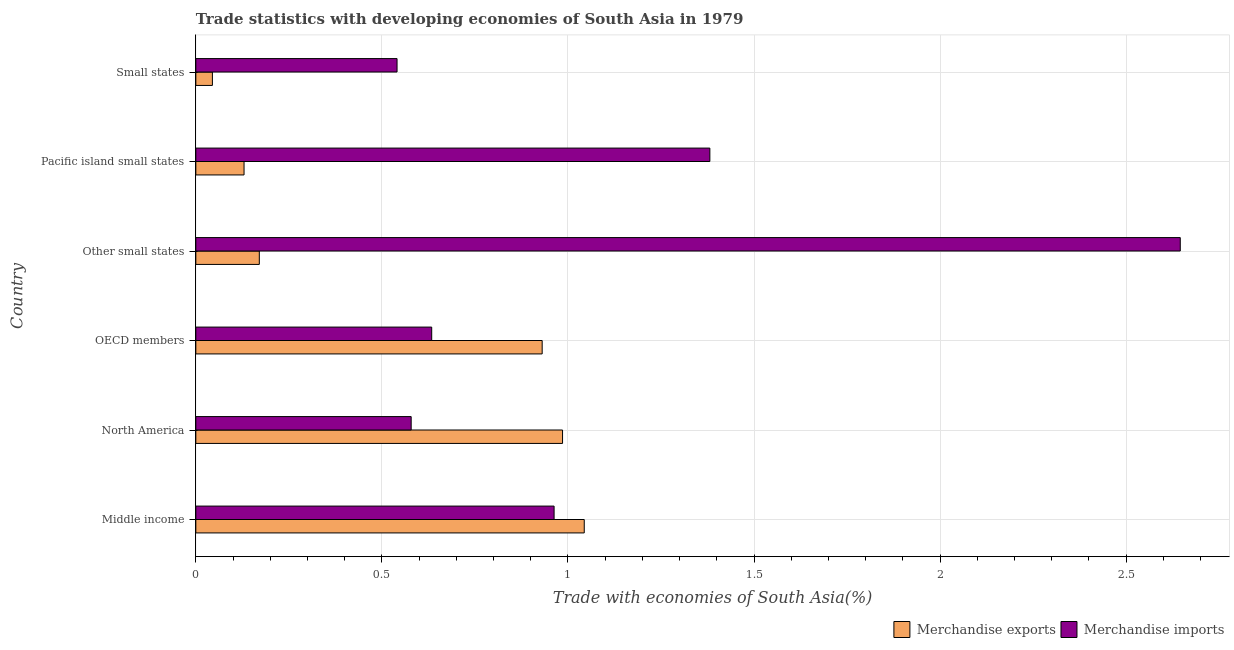How many different coloured bars are there?
Offer a terse response. 2. Are the number of bars on each tick of the Y-axis equal?
Offer a very short reply. Yes. How many bars are there on the 1st tick from the top?
Your answer should be compact. 2. How many bars are there on the 6th tick from the bottom?
Offer a terse response. 2. What is the merchandise exports in Small states?
Make the answer very short. 0.04. Across all countries, what is the maximum merchandise exports?
Your answer should be compact. 1.04. Across all countries, what is the minimum merchandise exports?
Your answer should be very brief. 0.04. In which country was the merchandise imports minimum?
Your answer should be compact. Small states. What is the total merchandise exports in the graph?
Offer a terse response. 3.3. What is the difference between the merchandise exports in OECD members and that in Small states?
Your response must be concise. 0.89. What is the difference between the merchandise exports in Middle income and the merchandise imports in Small states?
Keep it short and to the point. 0.5. What is the average merchandise exports per country?
Offer a very short reply. 0.55. What is the difference between the merchandise imports and merchandise exports in OECD members?
Ensure brevity in your answer.  -0.3. In how many countries, is the merchandise exports greater than 1.2 %?
Provide a short and direct response. 0. What is the ratio of the merchandise imports in Middle income to that in North America?
Make the answer very short. 1.66. Is the merchandise imports in Middle income less than that in Pacific island small states?
Keep it short and to the point. Yes. What is the difference between the highest and the second highest merchandise exports?
Your answer should be very brief. 0.06. What does the 1st bar from the top in Small states represents?
Your answer should be very brief. Merchandise imports. Are all the bars in the graph horizontal?
Keep it short and to the point. Yes. How many countries are there in the graph?
Your answer should be very brief. 6. What is the difference between two consecutive major ticks on the X-axis?
Give a very brief answer. 0.5. Does the graph contain grids?
Your answer should be compact. Yes. What is the title of the graph?
Provide a short and direct response. Trade statistics with developing economies of South Asia in 1979. What is the label or title of the X-axis?
Your answer should be compact. Trade with economies of South Asia(%). What is the label or title of the Y-axis?
Offer a terse response. Country. What is the Trade with economies of South Asia(%) in Merchandise exports in Middle income?
Offer a terse response. 1.04. What is the Trade with economies of South Asia(%) of Merchandise imports in Middle income?
Keep it short and to the point. 0.96. What is the Trade with economies of South Asia(%) in Merchandise exports in North America?
Provide a succinct answer. 0.99. What is the Trade with economies of South Asia(%) of Merchandise imports in North America?
Your response must be concise. 0.58. What is the Trade with economies of South Asia(%) in Merchandise exports in OECD members?
Make the answer very short. 0.93. What is the Trade with economies of South Asia(%) of Merchandise imports in OECD members?
Offer a terse response. 0.63. What is the Trade with economies of South Asia(%) in Merchandise exports in Other small states?
Ensure brevity in your answer.  0.17. What is the Trade with economies of South Asia(%) of Merchandise imports in Other small states?
Your response must be concise. 2.65. What is the Trade with economies of South Asia(%) in Merchandise exports in Pacific island small states?
Offer a terse response. 0.13. What is the Trade with economies of South Asia(%) in Merchandise imports in Pacific island small states?
Keep it short and to the point. 1.38. What is the Trade with economies of South Asia(%) of Merchandise exports in Small states?
Keep it short and to the point. 0.04. What is the Trade with economies of South Asia(%) in Merchandise imports in Small states?
Offer a very short reply. 0.54. Across all countries, what is the maximum Trade with economies of South Asia(%) of Merchandise exports?
Your response must be concise. 1.04. Across all countries, what is the maximum Trade with economies of South Asia(%) in Merchandise imports?
Your response must be concise. 2.65. Across all countries, what is the minimum Trade with economies of South Asia(%) of Merchandise exports?
Offer a very short reply. 0.04. Across all countries, what is the minimum Trade with economies of South Asia(%) of Merchandise imports?
Give a very brief answer. 0.54. What is the total Trade with economies of South Asia(%) of Merchandise exports in the graph?
Provide a succinct answer. 3.3. What is the total Trade with economies of South Asia(%) in Merchandise imports in the graph?
Make the answer very short. 6.74. What is the difference between the Trade with economies of South Asia(%) in Merchandise exports in Middle income and that in North America?
Ensure brevity in your answer.  0.06. What is the difference between the Trade with economies of South Asia(%) of Merchandise imports in Middle income and that in North America?
Offer a very short reply. 0.38. What is the difference between the Trade with economies of South Asia(%) in Merchandise exports in Middle income and that in OECD members?
Provide a succinct answer. 0.11. What is the difference between the Trade with economies of South Asia(%) of Merchandise imports in Middle income and that in OECD members?
Your answer should be compact. 0.33. What is the difference between the Trade with economies of South Asia(%) of Merchandise exports in Middle income and that in Other small states?
Offer a terse response. 0.87. What is the difference between the Trade with economies of South Asia(%) of Merchandise imports in Middle income and that in Other small states?
Your answer should be compact. -1.68. What is the difference between the Trade with economies of South Asia(%) in Merchandise exports in Middle income and that in Pacific island small states?
Your answer should be very brief. 0.91. What is the difference between the Trade with economies of South Asia(%) of Merchandise imports in Middle income and that in Pacific island small states?
Provide a short and direct response. -0.42. What is the difference between the Trade with economies of South Asia(%) in Merchandise exports in Middle income and that in Small states?
Provide a short and direct response. 1. What is the difference between the Trade with economies of South Asia(%) in Merchandise imports in Middle income and that in Small states?
Your answer should be very brief. 0.42. What is the difference between the Trade with economies of South Asia(%) in Merchandise exports in North America and that in OECD members?
Provide a succinct answer. 0.05. What is the difference between the Trade with economies of South Asia(%) of Merchandise imports in North America and that in OECD members?
Offer a very short reply. -0.06. What is the difference between the Trade with economies of South Asia(%) of Merchandise exports in North America and that in Other small states?
Your answer should be compact. 0.81. What is the difference between the Trade with economies of South Asia(%) of Merchandise imports in North America and that in Other small states?
Offer a terse response. -2.07. What is the difference between the Trade with economies of South Asia(%) in Merchandise exports in North America and that in Pacific island small states?
Your answer should be very brief. 0.86. What is the difference between the Trade with economies of South Asia(%) in Merchandise imports in North America and that in Pacific island small states?
Offer a terse response. -0.8. What is the difference between the Trade with economies of South Asia(%) in Merchandise exports in North America and that in Small states?
Provide a short and direct response. 0.94. What is the difference between the Trade with economies of South Asia(%) of Merchandise imports in North America and that in Small states?
Provide a short and direct response. 0.04. What is the difference between the Trade with economies of South Asia(%) of Merchandise exports in OECD members and that in Other small states?
Offer a very short reply. 0.76. What is the difference between the Trade with economies of South Asia(%) in Merchandise imports in OECD members and that in Other small states?
Ensure brevity in your answer.  -2.01. What is the difference between the Trade with economies of South Asia(%) of Merchandise exports in OECD members and that in Pacific island small states?
Ensure brevity in your answer.  0.8. What is the difference between the Trade with economies of South Asia(%) in Merchandise imports in OECD members and that in Pacific island small states?
Keep it short and to the point. -0.75. What is the difference between the Trade with economies of South Asia(%) in Merchandise exports in OECD members and that in Small states?
Ensure brevity in your answer.  0.89. What is the difference between the Trade with economies of South Asia(%) in Merchandise imports in OECD members and that in Small states?
Keep it short and to the point. 0.09. What is the difference between the Trade with economies of South Asia(%) in Merchandise exports in Other small states and that in Pacific island small states?
Ensure brevity in your answer.  0.04. What is the difference between the Trade with economies of South Asia(%) in Merchandise imports in Other small states and that in Pacific island small states?
Give a very brief answer. 1.26. What is the difference between the Trade with economies of South Asia(%) in Merchandise exports in Other small states and that in Small states?
Offer a very short reply. 0.13. What is the difference between the Trade with economies of South Asia(%) in Merchandise imports in Other small states and that in Small states?
Offer a terse response. 2.1. What is the difference between the Trade with economies of South Asia(%) in Merchandise exports in Pacific island small states and that in Small states?
Offer a very short reply. 0.09. What is the difference between the Trade with economies of South Asia(%) of Merchandise imports in Pacific island small states and that in Small states?
Your answer should be very brief. 0.84. What is the difference between the Trade with economies of South Asia(%) of Merchandise exports in Middle income and the Trade with economies of South Asia(%) of Merchandise imports in North America?
Make the answer very short. 0.47. What is the difference between the Trade with economies of South Asia(%) in Merchandise exports in Middle income and the Trade with economies of South Asia(%) in Merchandise imports in OECD members?
Keep it short and to the point. 0.41. What is the difference between the Trade with economies of South Asia(%) of Merchandise exports in Middle income and the Trade with economies of South Asia(%) of Merchandise imports in Other small states?
Keep it short and to the point. -1.6. What is the difference between the Trade with economies of South Asia(%) in Merchandise exports in Middle income and the Trade with economies of South Asia(%) in Merchandise imports in Pacific island small states?
Keep it short and to the point. -0.34. What is the difference between the Trade with economies of South Asia(%) in Merchandise exports in Middle income and the Trade with economies of South Asia(%) in Merchandise imports in Small states?
Give a very brief answer. 0.5. What is the difference between the Trade with economies of South Asia(%) in Merchandise exports in North America and the Trade with economies of South Asia(%) in Merchandise imports in OECD members?
Offer a very short reply. 0.35. What is the difference between the Trade with economies of South Asia(%) of Merchandise exports in North America and the Trade with economies of South Asia(%) of Merchandise imports in Other small states?
Your answer should be compact. -1.66. What is the difference between the Trade with economies of South Asia(%) in Merchandise exports in North America and the Trade with economies of South Asia(%) in Merchandise imports in Pacific island small states?
Provide a short and direct response. -0.4. What is the difference between the Trade with economies of South Asia(%) of Merchandise exports in North America and the Trade with economies of South Asia(%) of Merchandise imports in Small states?
Offer a terse response. 0.44. What is the difference between the Trade with economies of South Asia(%) of Merchandise exports in OECD members and the Trade with economies of South Asia(%) of Merchandise imports in Other small states?
Your answer should be compact. -1.71. What is the difference between the Trade with economies of South Asia(%) in Merchandise exports in OECD members and the Trade with economies of South Asia(%) in Merchandise imports in Pacific island small states?
Keep it short and to the point. -0.45. What is the difference between the Trade with economies of South Asia(%) of Merchandise exports in OECD members and the Trade with economies of South Asia(%) of Merchandise imports in Small states?
Your answer should be very brief. 0.39. What is the difference between the Trade with economies of South Asia(%) of Merchandise exports in Other small states and the Trade with economies of South Asia(%) of Merchandise imports in Pacific island small states?
Provide a short and direct response. -1.21. What is the difference between the Trade with economies of South Asia(%) of Merchandise exports in Other small states and the Trade with economies of South Asia(%) of Merchandise imports in Small states?
Offer a very short reply. -0.37. What is the difference between the Trade with economies of South Asia(%) in Merchandise exports in Pacific island small states and the Trade with economies of South Asia(%) in Merchandise imports in Small states?
Offer a terse response. -0.41. What is the average Trade with economies of South Asia(%) of Merchandise exports per country?
Ensure brevity in your answer.  0.55. What is the average Trade with economies of South Asia(%) in Merchandise imports per country?
Provide a succinct answer. 1.12. What is the difference between the Trade with economies of South Asia(%) of Merchandise exports and Trade with economies of South Asia(%) of Merchandise imports in Middle income?
Your answer should be very brief. 0.08. What is the difference between the Trade with economies of South Asia(%) in Merchandise exports and Trade with economies of South Asia(%) in Merchandise imports in North America?
Offer a terse response. 0.41. What is the difference between the Trade with economies of South Asia(%) in Merchandise exports and Trade with economies of South Asia(%) in Merchandise imports in OECD members?
Offer a very short reply. 0.3. What is the difference between the Trade with economies of South Asia(%) in Merchandise exports and Trade with economies of South Asia(%) in Merchandise imports in Other small states?
Offer a terse response. -2.47. What is the difference between the Trade with economies of South Asia(%) in Merchandise exports and Trade with economies of South Asia(%) in Merchandise imports in Pacific island small states?
Give a very brief answer. -1.25. What is the difference between the Trade with economies of South Asia(%) in Merchandise exports and Trade with economies of South Asia(%) in Merchandise imports in Small states?
Your answer should be compact. -0.5. What is the ratio of the Trade with economies of South Asia(%) of Merchandise exports in Middle income to that in North America?
Your answer should be compact. 1.06. What is the ratio of the Trade with economies of South Asia(%) of Merchandise imports in Middle income to that in North America?
Make the answer very short. 1.66. What is the ratio of the Trade with economies of South Asia(%) of Merchandise exports in Middle income to that in OECD members?
Offer a terse response. 1.12. What is the ratio of the Trade with economies of South Asia(%) of Merchandise imports in Middle income to that in OECD members?
Your response must be concise. 1.52. What is the ratio of the Trade with economies of South Asia(%) of Merchandise exports in Middle income to that in Other small states?
Offer a terse response. 6.12. What is the ratio of the Trade with economies of South Asia(%) of Merchandise imports in Middle income to that in Other small states?
Offer a very short reply. 0.36. What is the ratio of the Trade with economies of South Asia(%) of Merchandise exports in Middle income to that in Pacific island small states?
Your answer should be very brief. 8.05. What is the ratio of the Trade with economies of South Asia(%) in Merchandise imports in Middle income to that in Pacific island small states?
Give a very brief answer. 0.7. What is the ratio of the Trade with economies of South Asia(%) of Merchandise exports in Middle income to that in Small states?
Your answer should be compact. 23.44. What is the ratio of the Trade with economies of South Asia(%) of Merchandise imports in Middle income to that in Small states?
Give a very brief answer. 1.78. What is the ratio of the Trade with economies of South Asia(%) in Merchandise exports in North America to that in OECD members?
Provide a succinct answer. 1.06. What is the ratio of the Trade with economies of South Asia(%) of Merchandise exports in North America to that in Other small states?
Ensure brevity in your answer.  5.78. What is the ratio of the Trade with economies of South Asia(%) in Merchandise imports in North America to that in Other small states?
Your answer should be compact. 0.22. What is the ratio of the Trade with economies of South Asia(%) of Merchandise exports in North America to that in Pacific island small states?
Make the answer very short. 7.6. What is the ratio of the Trade with economies of South Asia(%) of Merchandise imports in North America to that in Pacific island small states?
Offer a very short reply. 0.42. What is the ratio of the Trade with economies of South Asia(%) of Merchandise exports in North America to that in Small states?
Make the answer very short. 22.13. What is the ratio of the Trade with economies of South Asia(%) of Merchandise imports in North America to that in Small states?
Offer a very short reply. 1.07. What is the ratio of the Trade with economies of South Asia(%) in Merchandise exports in OECD members to that in Other small states?
Give a very brief answer. 5.46. What is the ratio of the Trade with economies of South Asia(%) in Merchandise imports in OECD members to that in Other small states?
Your response must be concise. 0.24. What is the ratio of the Trade with economies of South Asia(%) in Merchandise exports in OECD members to that in Pacific island small states?
Ensure brevity in your answer.  7.18. What is the ratio of the Trade with economies of South Asia(%) of Merchandise imports in OECD members to that in Pacific island small states?
Keep it short and to the point. 0.46. What is the ratio of the Trade with economies of South Asia(%) in Merchandise exports in OECD members to that in Small states?
Offer a terse response. 20.9. What is the ratio of the Trade with economies of South Asia(%) in Merchandise imports in OECD members to that in Small states?
Provide a short and direct response. 1.17. What is the ratio of the Trade with economies of South Asia(%) in Merchandise exports in Other small states to that in Pacific island small states?
Provide a short and direct response. 1.32. What is the ratio of the Trade with economies of South Asia(%) of Merchandise imports in Other small states to that in Pacific island small states?
Ensure brevity in your answer.  1.92. What is the ratio of the Trade with economies of South Asia(%) in Merchandise exports in Other small states to that in Small states?
Offer a very short reply. 3.83. What is the ratio of the Trade with economies of South Asia(%) of Merchandise imports in Other small states to that in Small states?
Provide a short and direct response. 4.89. What is the ratio of the Trade with economies of South Asia(%) of Merchandise exports in Pacific island small states to that in Small states?
Provide a short and direct response. 2.91. What is the ratio of the Trade with economies of South Asia(%) in Merchandise imports in Pacific island small states to that in Small states?
Ensure brevity in your answer.  2.55. What is the difference between the highest and the second highest Trade with economies of South Asia(%) in Merchandise exports?
Offer a terse response. 0.06. What is the difference between the highest and the second highest Trade with economies of South Asia(%) in Merchandise imports?
Ensure brevity in your answer.  1.26. What is the difference between the highest and the lowest Trade with economies of South Asia(%) in Merchandise imports?
Ensure brevity in your answer.  2.1. 